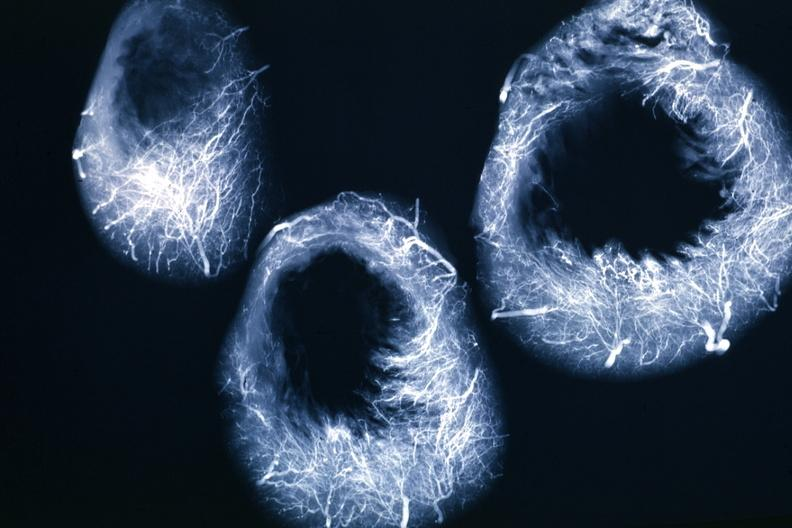s tuberculosis present?
Answer the question using a single word or phrase. No 